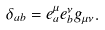<formula> <loc_0><loc_0><loc_500><loc_500>\delta _ { a b } = e _ { a } ^ { \mu } e _ { b } ^ { \nu } g _ { \mu \nu } .</formula> 